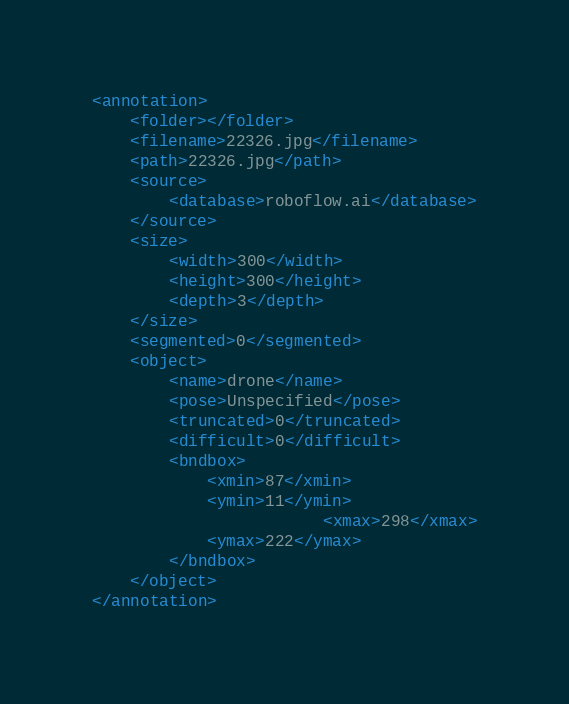Convert code to text. <code><loc_0><loc_0><loc_500><loc_500><_XML_><annotation>
	<folder></folder>
	<filename>22326.jpg</filename>
	<path>22326.jpg</path>
	<source>
		<database>roboflow.ai</database>
	</source>
	<size>
		<width>300</width>
		<height>300</height>
		<depth>3</depth>
	</size>
	<segmented>0</segmented>
	<object>
		<name>drone</name>
		<pose>Unspecified</pose>
		<truncated>0</truncated>
		<difficult>0</difficult>
		<bndbox>
			<xmin>87</xmin>
			<ymin>11</ymin>
                        <xmax>298</xmax>
			<ymax>222</ymax>
		</bndbox>
	</object>
</annotation>
</code> 